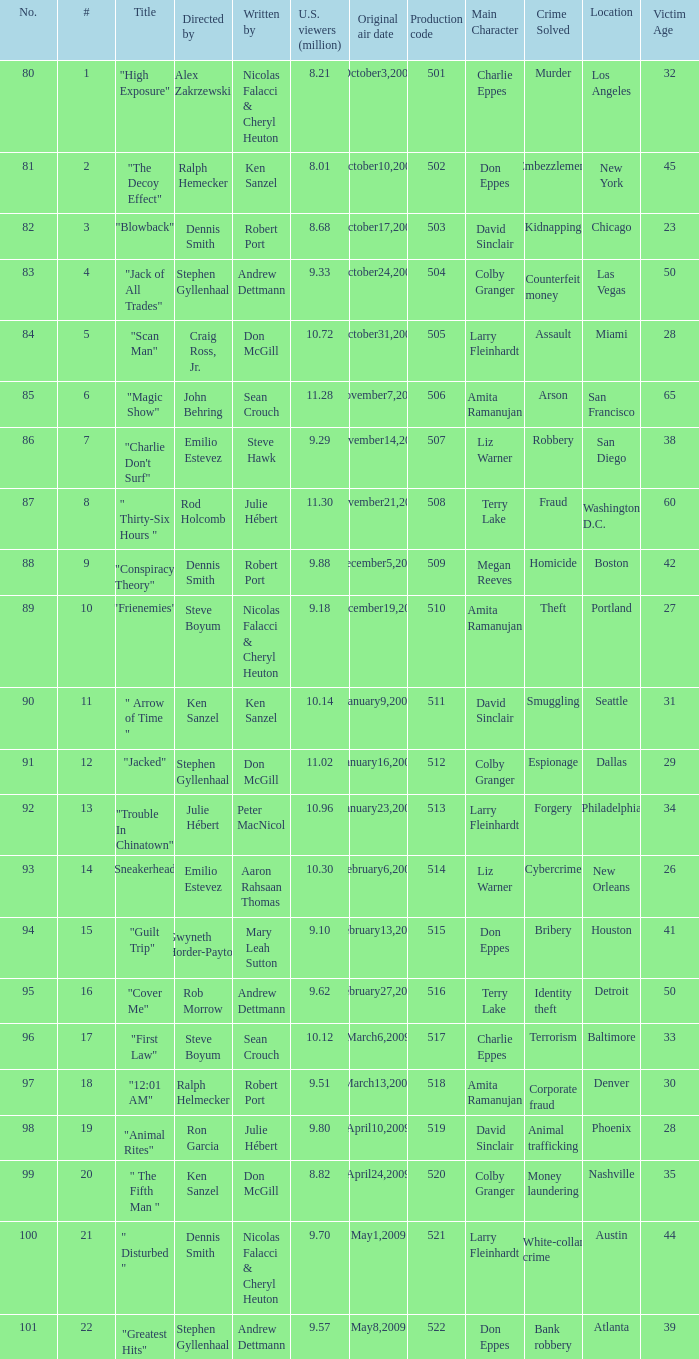Which episode number was helmed by craig ross, jr.? 5.0. 